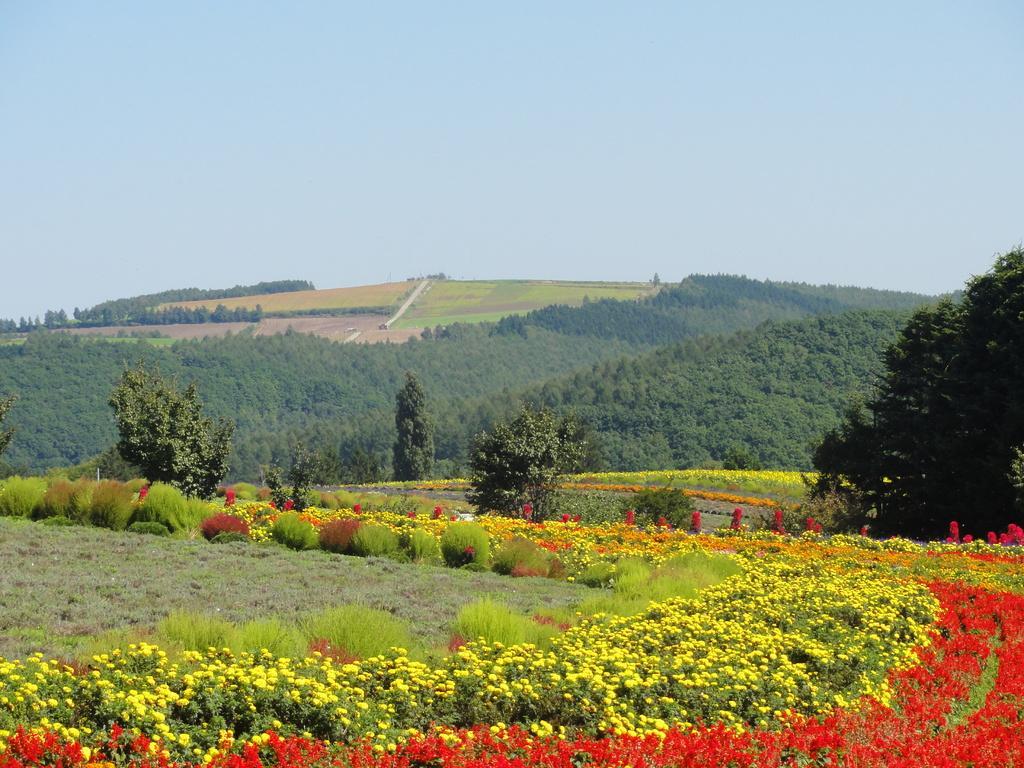In one or two sentences, can you explain what this image depicts? In this picture I can see number of plants in front on which there are flowers which are of red and yellow in color. In the background I see number of trees and I see the sky. 